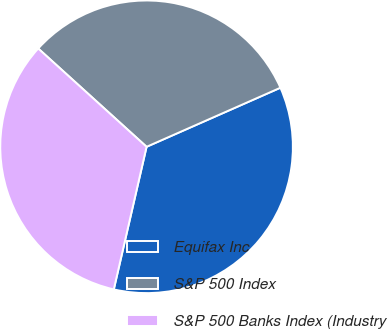Convert chart. <chart><loc_0><loc_0><loc_500><loc_500><pie_chart><fcel>Equifax Inc<fcel>S&P 500 Index<fcel>S&P 500 Banks Index (Industry<nl><fcel>35.21%<fcel>31.66%<fcel>33.13%<nl></chart> 